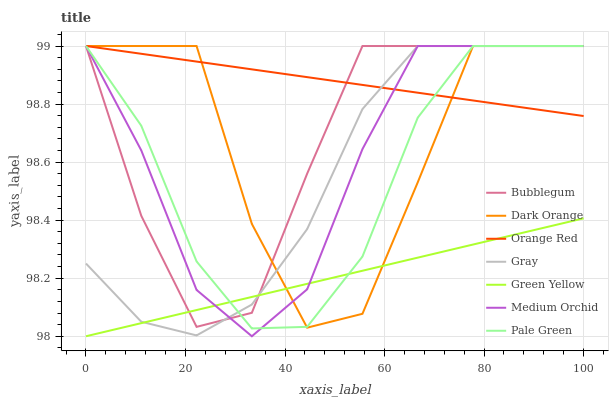Does Green Yellow have the minimum area under the curve?
Answer yes or no. Yes. Does Orange Red have the maximum area under the curve?
Answer yes or no. Yes. Does Gray have the minimum area under the curve?
Answer yes or no. No. Does Gray have the maximum area under the curve?
Answer yes or no. No. Is Orange Red the smoothest?
Answer yes or no. Yes. Is Dark Orange the roughest?
Answer yes or no. Yes. Is Gray the smoothest?
Answer yes or no. No. Is Gray the roughest?
Answer yes or no. No. Does Gray have the lowest value?
Answer yes or no. No. Does Orange Red have the highest value?
Answer yes or no. Yes. Does Green Yellow have the highest value?
Answer yes or no. No. Is Green Yellow less than Orange Red?
Answer yes or no. Yes. Is Orange Red greater than Green Yellow?
Answer yes or no. Yes. Does Green Yellow intersect Dark Orange?
Answer yes or no. Yes. Is Green Yellow less than Dark Orange?
Answer yes or no. No. Is Green Yellow greater than Dark Orange?
Answer yes or no. No. Does Green Yellow intersect Orange Red?
Answer yes or no. No. 